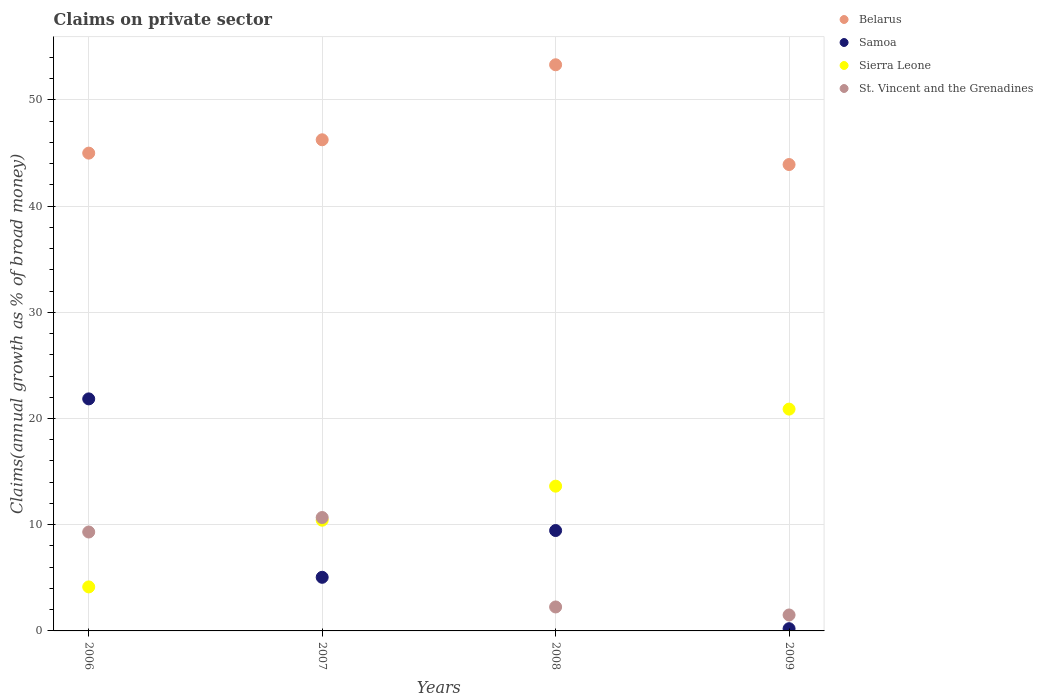How many different coloured dotlines are there?
Offer a very short reply. 4. Is the number of dotlines equal to the number of legend labels?
Keep it short and to the point. Yes. What is the percentage of broad money claimed on private sector in Samoa in 2006?
Your answer should be very brief. 21.85. Across all years, what is the maximum percentage of broad money claimed on private sector in Sierra Leone?
Provide a succinct answer. 20.88. Across all years, what is the minimum percentage of broad money claimed on private sector in Samoa?
Give a very brief answer. 0.21. In which year was the percentage of broad money claimed on private sector in Sierra Leone maximum?
Provide a short and direct response. 2009. What is the total percentage of broad money claimed on private sector in Belarus in the graph?
Offer a very short reply. 188.45. What is the difference between the percentage of broad money claimed on private sector in Belarus in 2006 and that in 2009?
Make the answer very short. 1.07. What is the difference between the percentage of broad money claimed on private sector in Belarus in 2006 and the percentage of broad money claimed on private sector in St. Vincent and the Grenadines in 2007?
Give a very brief answer. 34.31. What is the average percentage of broad money claimed on private sector in St. Vincent and the Grenadines per year?
Make the answer very short. 5.94. In the year 2007, what is the difference between the percentage of broad money claimed on private sector in Samoa and percentage of broad money claimed on private sector in St. Vincent and the Grenadines?
Provide a short and direct response. -5.63. What is the ratio of the percentage of broad money claimed on private sector in Sierra Leone in 2006 to that in 2008?
Offer a very short reply. 0.3. Is the percentage of broad money claimed on private sector in Belarus in 2007 less than that in 2008?
Your response must be concise. Yes. What is the difference between the highest and the second highest percentage of broad money claimed on private sector in St. Vincent and the Grenadines?
Offer a terse response. 1.36. What is the difference between the highest and the lowest percentage of broad money claimed on private sector in St. Vincent and the Grenadines?
Your answer should be compact. 9.18. In how many years, is the percentage of broad money claimed on private sector in Samoa greater than the average percentage of broad money claimed on private sector in Samoa taken over all years?
Provide a short and direct response. 2. Is it the case that in every year, the sum of the percentage of broad money claimed on private sector in Belarus and percentage of broad money claimed on private sector in St. Vincent and the Grenadines  is greater than the sum of percentage of broad money claimed on private sector in Sierra Leone and percentage of broad money claimed on private sector in Samoa?
Your answer should be compact. Yes. Is it the case that in every year, the sum of the percentage of broad money claimed on private sector in St. Vincent and the Grenadines and percentage of broad money claimed on private sector in Sierra Leone  is greater than the percentage of broad money claimed on private sector in Samoa?
Your answer should be very brief. No. Is the percentage of broad money claimed on private sector in St. Vincent and the Grenadines strictly greater than the percentage of broad money claimed on private sector in Sierra Leone over the years?
Give a very brief answer. No. Is the percentage of broad money claimed on private sector in Belarus strictly less than the percentage of broad money claimed on private sector in Sierra Leone over the years?
Your answer should be very brief. No. How many years are there in the graph?
Your response must be concise. 4. What is the difference between two consecutive major ticks on the Y-axis?
Keep it short and to the point. 10. Are the values on the major ticks of Y-axis written in scientific E-notation?
Your answer should be very brief. No. Where does the legend appear in the graph?
Make the answer very short. Top right. How many legend labels are there?
Provide a short and direct response. 4. What is the title of the graph?
Offer a very short reply. Claims on private sector. Does "Sub-Saharan Africa (developing only)" appear as one of the legend labels in the graph?
Keep it short and to the point. No. What is the label or title of the Y-axis?
Make the answer very short. Claims(annual growth as % of broad money). What is the Claims(annual growth as % of broad money) in Belarus in 2006?
Give a very brief answer. 44.99. What is the Claims(annual growth as % of broad money) of Samoa in 2006?
Give a very brief answer. 21.85. What is the Claims(annual growth as % of broad money) of Sierra Leone in 2006?
Your answer should be very brief. 4.14. What is the Claims(annual growth as % of broad money) in St. Vincent and the Grenadines in 2006?
Make the answer very short. 9.31. What is the Claims(annual growth as % of broad money) of Belarus in 2007?
Make the answer very short. 46.24. What is the Claims(annual growth as % of broad money) of Samoa in 2007?
Your response must be concise. 5.05. What is the Claims(annual growth as % of broad money) in Sierra Leone in 2007?
Keep it short and to the point. 10.42. What is the Claims(annual growth as % of broad money) in St. Vincent and the Grenadines in 2007?
Offer a very short reply. 10.68. What is the Claims(annual growth as % of broad money) in Belarus in 2008?
Keep it short and to the point. 53.31. What is the Claims(annual growth as % of broad money) of Samoa in 2008?
Make the answer very short. 9.45. What is the Claims(annual growth as % of broad money) of Sierra Leone in 2008?
Ensure brevity in your answer.  13.63. What is the Claims(annual growth as % of broad money) of St. Vincent and the Grenadines in 2008?
Keep it short and to the point. 2.26. What is the Claims(annual growth as % of broad money) of Belarus in 2009?
Make the answer very short. 43.91. What is the Claims(annual growth as % of broad money) of Samoa in 2009?
Provide a short and direct response. 0.21. What is the Claims(annual growth as % of broad money) of Sierra Leone in 2009?
Provide a short and direct response. 20.88. What is the Claims(annual growth as % of broad money) of St. Vincent and the Grenadines in 2009?
Give a very brief answer. 1.5. Across all years, what is the maximum Claims(annual growth as % of broad money) in Belarus?
Provide a succinct answer. 53.31. Across all years, what is the maximum Claims(annual growth as % of broad money) in Samoa?
Your answer should be very brief. 21.85. Across all years, what is the maximum Claims(annual growth as % of broad money) in Sierra Leone?
Provide a succinct answer. 20.88. Across all years, what is the maximum Claims(annual growth as % of broad money) in St. Vincent and the Grenadines?
Ensure brevity in your answer.  10.68. Across all years, what is the minimum Claims(annual growth as % of broad money) of Belarus?
Provide a short and direct response. 43.91. Across all years, what is the minimum Claims(annual growth as % of broad money) in Samoa?
Give a very brief answer. 0.21. Across all years, what is the minimum Claims(annual growth as % of broad money) of Sierra Leone?
Your answer should be very brief. 4.14. Across all years, what is the minimum Claims(annual growth as % of broad money) in St. Vincent and the Grenadines?
Give a very brief answer. 1.5. What is the total Claims(annual growth as % of broad money) in Belarus in the graph?
Offer a very short reply. 188.45. What is the total Claims(annual growth as % of broad money) of Samoa in the graph?
Make the answer very short. 36.56. What is the total Claims(annual growth as % of broad money) of Sierra Leone in the graph?
Your answer should be very brief. 49.08. What is the total Claims(annual growth as % of broad money) in St. Vincent and the Grenadines in the graph?
Your answer should be very brief. 23.75. What is the difference between the Claims(annual growth as % of broad money) of Belarus in 2006 and that in 2007?
Provide a short and direct response. -1.26. What is the difference between the Claims(annual growth as % of broad money) in Samoa in 2006 and that in 2007?
Offer a terse response. 16.8. What is the difference between the Claims(annual growth as % of broad money) in Sierra Leone in 2006 and that in 2007?
Keep it short and to the point. -6.28. What is the difference between the Claims(annual growth as % of broad money) of St. Vincent and the Grenadines in 2006 and that in 2007?
Keep it short and to the point. -1.36. What is the difference between the Claims(annual growth as % of broad money) of Belarus in 2006 and that in 2008?
Ensure brevity in your answer.  -8.32. What is the difference between the Claims(annual growth as % of broad money) in Samoa in 2006 and that in 2008?
Your answer should be very brief. 12.4. What is the difference between the Claims(annual growth as % of broad money) in Sierra Leone in 2006 and that in 2008?
Give a very brief answer. -9.49. What is the difference between the Claims(annual growth as % of broad money) of St. Vincent and the Grenadines in 2006 and that in 2008?
Offer a terse response. 7.06. What is the difference between the Claims(annual growth as % of broad money) of Belarus in 2006 and that in 2009?
Give a very brief answer. 1.07. What is the difference between the Claims(annual growth as % of broad money) of Samoa in 2006 and that in 2009?
Provide a short and direct response. 21.64. What is the difference between the Claims(annual growth as % of broad money) of Sierra Leone in 2006 and that in 2009?
Keep it short and to the point. -16.74. What is the difference between the Claims(annual growth as % of broad money) in St. Vincent and the Grenadines in 2006 and that in 2009?
Your answer should be very brief. 7.81. What is the difference between the Claims(annual growth as % of broad money) of Belarus in 2007 and that in 2008?
Offer a very short reply. -7.06. What is the difference between the Claims(annual growth as % of broad money) in Samoa in 2007 and that in 2008?
Give a very brief answer. -4.4. What is the difference between the Claims(annual growth as % of broad money) of Sierra Leone in 2007 and that in 2008?
Provide a succinct answer. -3.21. What is the difference between the Claims(annual growth as % of broad money) in St. Vincent and the Grenadines in 2007 and that in 2008?
Provide a short and direct response. 8.42. What is the difference between the Claims(annual growth as % of broad money) of Belarus in 2007 and that in 2009?
Offer a terse response. 2.33. What is the difference between the Claims(annual growth as % of broad money) of Samoa in 2007 and that in 2009?
Provide a succinct answer. 4.84. What is the difference between the Claims(annual growth as % of broad money) of Sierra Leone in 2007 and that in 2009?
Your answer should be compact. -10.46. What is the difference between the Claims(annual growth as % of broad money) of St. Vincent and the Grenadines in 2007 and that in 2009?
Offer a terse response. 9.18. What is the difference between the Claims(annual growth as % of broad money) in Belarus in 2008 and that in 2009?
Your response must be concise. 9.39. What is the difference between the Claims(annual growth as % of broad money) of Samoa in 2008 and that in 2009?
Provide a short and direct response. 9.24. What is the difference between the Claims(annual growth as % of broad money) in Sierra Leone in 2008 and that in 2009?
Ensure brevity in your answer.  -7.25. What is the difference between the Claims(annual growth as % of broad money) of St. Vincent and the Grenadines in 2008 and that in 2009?
Keep it short and to the point. 0.75. What is the difference between the Claims(annual growth as % of broad money) of Belarus in 2006 and the Claims(annual growth as % of broad money) of Samoa in 2007?
Make the answer very short. 39.94. What is the difference between the Claims(annual growth as % of broad money) of Belarus in 2006 and the Claims(annual growth as % of broad money) of Sierra Leone in 2007?
Your answer should be compact. 34.56. What is the difference between the Claims(annual growth as % of broad money) in Belarus in 2006 and the Claims(annual growth as % of broad money) in St. Vincent and the Grenadines in 2007?
Ensure brevity in your answer.  34.31. What is the difference between the Claims(annual growth as % of broad money) of Samoa in 2006 and the Claims(annual growth as % of broad money) of Sierra Leone in 2007?
Offer a very short reply. 11.42. What is the difference between the Claims(annual growth as % of broad money) of Samoa in 2006 and the Claims(annual growth as % of broad money) of St. Vincent and the Grenadines in 2007?
Provide a succinct answer. 11.17. What is the difference between the Claims(annual growth as % of broad money) of Sierra Leone in 2006 and the Claims(annual growth as % of broad money) of St. Vincent and the Grenadines in 2007?
Provide a succinct answer. -6.53. What is the difference between the Claims(annual growth as % of broad money) in Belarus in 2006 and the Claims(annual growth as % of broad money) in Samoa in 2008?
Ensure brevity in your answer.  35.54. What is the difference between the Claims(annual growth as % of broad money) of Belarus in 2006 and the Claims(annual growth as % of broad money) of Sierra Leone in 2008?
Your response must be concise. 31.36. What is the difference between the Claims(annual growth as % of broad money) of Belarus in 2006 and the Claims(annual growth as % of broad money) of St. Vincent and the Grenadines in 2008?
Ensure brevity in your answer.  42.73. What is the difference between the Claims(annual growth as % of broad money) of Samoa in 2006 and the Claims(annual growth as % of broad money) of Sierra Leone in 2008?
Your response must be concise. 8.22. What is the difference between the Claims(annual growth as % of broad money) of Samoa in 2006 and the Claims(annual growth as % of broad money) of St. Vincent and the Grenadines in 2008?
Ensure brevity in your answer.  19.59. What is the difference between the Claims(annual growth as % of broad money) in Sierra Leone in 2006 and the Claims(annual growth as % of broad money) in St. Vincent and the Grenadines in 2008?
Give a very brief answer. 1.89. What is the difference between the Claims(annual growth as % of broad money) of Belarus in 2006 and the Claims(annual growth as % of broad money) of Samoa in 2009?
Your answer should be compact. 44.78. What is the difference between the Claims(annual growth as % of broad money) in Belarus in 2006 and the Claims(annual growth as % of broad money) in Sierra Leone in 2009?
Your answer should be compact. 24.1. What is the difference between the Claims(annual growth as % of broad money) in Belarus in 2006 and the Claims(annual growth as % of broad money) in St. Vincent and the Grenadines in 2009?
Provide a short and direct response. 43.49. What is the difference between the Claims(annual growth as % of broad money) of Samoa in 2006 and the Claims(annual growth as % of broad money) of Sierra Leone in 2009?
Give a very brief answer. 0.96. What is the difference between the Claims(annual growth as % of broad money) in Samoa in 2006 and the Claims(annual growth as % of broad money) in St. Vincent and the Grenadines in 2009?
Give a very brief answer. 20.35. What is the difference between the Claims(annual growth as % of broad money) in Sierra Leone in 2006 and the Claims(annual growth as % of broad money) in St. Vincent and the Grenadines in 2009?
Offer a terse response. 2.64. What is the difference between the Claims(annual growth as % of broad money) in Belarus in 2007 and the Claims(annual growth as % of broad money) in Samoa in 2008?
Ensure brevity in your answer.  36.79. What is the difference between the Claims(annual growth as % of broad money) in Belarus in 2007 and the Claims(annual growth as % of broad money) in Sierra Leone in 2008?
Provide a short and direct response. 32.61. What is the difference between the Claims(annual growth as % of broad money) of Belarus in 2007 and the Claims(annual growth as % of broad money) of St. Vincent and the Grenadines in 2008?
Offer a very short reply. 43.99. What is the difference between the Claims(annual growth as % of broad money) in Samoa in 2007 and the Claims(annual growth as % of broad money) in Sierra Leone in 2008?
Offer a terse response. -8.58. What is the difference between the Claims(annual growth as % of broad money) in Samoa in 2007 and the Claims(annual growth as % of broad money) in St. Vincent and the Grenadines in 2008?
Provide a short and direct response. 2.79. What is the difference between the Claims(annual growth as % of broad money) of Sierra Leone in 2007 and the Claims(annual growth as % of broad money) of St. Vincent and the Grenadines in 2008?
Offer a terse response. 8.17. What is the difference between the Claims(annual growth as % of broad money) in Belarus in 2007 and the Claims(annual growth as % of broad money) in Samoa in 2009?
Your answer should be very brief. 46.03. What is the difference between the Claims(annual growth as % of broad money) in Belarus in 2007 and the Claims(annual growth as % of broad money) in Sierra Leone in 2009?
Provide a short and direct response. 25.36. What is the difference between the Claims(annual growth as % of broad money) in Belarus in 2007 and the Claims(annual growth as % of broad money) in St. Vincent and the Grenadines in 2009?
Give a very brief answer. 44.74. What is the difference between the Claims(annual growth as % of broad money) in Samoa in 2007 and the Claims(annual growth as % of broad money) in Sierra Leone in 2009?
Your answer should be compact. -15.84. What is the difference between the Claims(annual growth as % of broad money) in Samoa in 2007 and the Claims(annual growth as % of broad money) in St. Vincent and the Grenadines in 2009?
Give a very brief answer. 3.55. What is the difference between the Claims(annual growth as % of broad money) of Sierra Leone in 2007 and the Claims(annual growth as % of broad money) of St. Vincent and the Grenadines in 2009?
Offer a terse response. 8.92. What is the difference between the Claims(annual growth as % of broad money) in Belarus in 2008 and the Claims(annual growth as % of broad money) in Samoa in 2009?
Your answer should be very brief. 53.1. What is the difference between the Claims(annual growth as % of broad money) of Belarus in 2008 and the Claims(annual growth as % of broad money) of Sierra Leone in 2009?
Offer a terse response. 32.42. What is the difference between the Claims(annual growth as % of broad money) of Belarus in 2008 and the Claims(annual growth as % of broad money) of St. Vincent and the Grenadines in 2009?
Keep it short and to the point. 51.81. What is the difference between the Claims(annual growth as % of broad money) in Samoa in 2008 and the Claims(annual growth as % of broad money) in Sierra Leone in 2009?
Offer a terse response. -11.43. What is the difference between the Claims(annual growth as % of broad money) in Samoa in 2008 and the Claims(annual growth as % of broad money) in St. Vincent and the Grenadines in 2009?
Offer a very short reply. 7.95. What is the difference between the Claims(annual growth as % of broad money) in Sierra Leone in 2008 and the Claims(annual growth as % of broad money) in St. Vincent and the Grenadines in 2009?
Your answer should be very brief. 12.13. What is the average Claims(annual growth as % of broad money) in Belarus per year?
Ensure brevity in your answer.  47.11. What is the average Claims(annual growth as % of broad money) of Samoa per year?
Your response must be concise. 9.14. What is the average Claims(annual growth as % of broad money) in Sierra Leone per year?
Make the answer very short. 12.27. What is the average Claims(annual growth as % of broad money) of St. Vincent and the Grenadines per year?
Keep it short and to the point. 5.94. In the year 2006, what is the difference between the Claims(annual growth as % of broad money) of Belarus and Claims(annual growth as % of broad money) of Samoa?
Make the answer very short. 23.14. In the year 2006, what is the difference between the Claims(annual growth as % of broad money) in Belarus and Claims(annual growth as % of broad money) in Sierra Leone?
Your response must be concise. 40.84. In the year 2006, what is the difference between the Claims(annual growth as % of broad money) of Belarus and Claims(annual growth as % of broad money) of St. Vincent and the Grenadines?
Provide a short and direct response. 35.67. In the year 2006, what is the difference between the Claims(annual growth as % of broad money) in Samoa and Claims(annual growth as % of broad money) in Sierra Leone?
Offer a terse response. 17.7. In the year 2006, what is the difference between the Claims(annual growth as % of broad money) in Samoa and Claims(annual growth as % of broad money) in St. Vincent and the Grenadines?
Offer a terse response. 12.53. In the year 2006, what is the difference between the Claims(annual growth as % of broad money) of Sierra Leone and Claims(annual growth as % of broad money) of St. Vincent and the Grenadines?
Ensure brevity in your answer.  -5.17. In the year 2007, what is the difference between the Claims(annual growth as % of broad money) of Belarus and Claims(annual growth as % of broad money) of Samoa?
Make the answer very short. 41.2. In the year 2007, what is the difference between the Claims(annual growth as % of broad money) of Belarus and Claims(annual growth as % of broad money) of Sierra Leone?
Keep it short and to the point. 35.82. In the year 2007, what is the difference between the Claims(annual growth as % of broad money) of Belarus and Claims(annual growth as % of broad money) of St. Vincent and the Grenadines?
Make the answer very short. 35.57. In the year 2007, what is the difference between the Claims(annual growth as % of broad money) of Samoa and Claims(annual growth as % of broad money) of Sierra Leone?
Provide a succinct answer. -5.38. In the year 2007, what is the difference between the Claims(annual growth as % of broad money) of Samoa and Claims(annual growth as % of broad money) of St. Vincent and the Grenadines?
Your answer should be compact. -5.63. In the year 2007, what is the difference between the Claims(annual growth as % of broad money) in Sierra Leone and Claims(annual growth as % of broad money) in St. Vincent and the Grenadines?
Ensure brevity in your answer.  -0.25. In the year 2008, what is the difference between the Claims(annual growth as % of broad money) of Belarus and Claims(annual growth as % of broad money) of Samoa?
Provide a succinct answer. 43.85. In the year 2008, what is the difference between the Claims(annual growth as % of broad money) in Belarus and Claims(annual growth as % of broad money) in Sierra Leone?
Your answer should be compact. 39.68. In the year 2008, what is the difference between the Claims(annual growth as % of broad money) in Belarus and Claims(annual growth as % of broad money) in St. Vincent and the Grenadines?
Make the answer very short. 51.05. In the year 2008, what is the difference between the Claims(annual growth as % of broad money) of Samoa and Claims(annual growth as % of broad money) of Sierra Leone?
Your response must be concise. -4.18. In the year 2008, what is the difference between the Claims(annual growth as % of broad money) in Samoa and Claims(annual growth as % of broad money) in St. Vincent and the Grenadines?
Your response must be concise. 7.2. In the year 2008, what is the difference between the Claims(annual growth as % of broad money) of Sierra Leone and Claims(annual growth as % of broad money) of St. Vincent and the Grenadines?
Provide a succinct answer. 11.37. In the year 2009, what is the difference between the Claims(annual growth as % of broad money) in Belarus and Claims(annual growth as % of broad money) in Samoa?
Ensure brevity in your answer.  43.7. In the year 2009, what is the difference between the Claims(annual growth as % of broad money) of Belarus and Claims(annual growth as % of broad money) of Sierra Leone?
Your response must be concise. 23.03. In the year 2009, what is the difference between the Claims(annual growth as % of broad money) of Belarus and Claims(annual growth as % of broad money) of St. Vincent and the Grenadines?
Ensure brevity in your answer.  42.41. In the year 2009, what is the difference between the Claims(annual growth as % of broad money) of Samoa and Claims(annual growth as % of broad money) of Sierra Leone?
Offer a terse response. -20.67. In the year 2009, what is the difference between the Claims(annual growth as % of broad money) of Samoa and Claims(annual growth as % of broad money) of St. Vincent and the Grenadines?
Your response must be concise. -1.29. In the year 2009, what is the difference between the Claims(annual growth as % of broad money) in Sierra Leone and Claims(annual growth as % of broad money) in St. Vincent and the Grenadines?
Offer a very short reply. 19.38. What is the ratio of the Claims(annual growth as % of broad money) of Belarus in 2006 to that in 2007?
Provide a succinct answer. 0.97. What is the ratio of the Claims(annual growth as % of broad money) in Samoa in 2006 to that in 2007?
Provide a short and direct response. 4.33. What is the ratio of the Claims(annual growth as % of broad money) of Sierra Leone in 2006 to that in 2007?
Provide a short and direct response. 0.4. What is the ratio of the Claims(annual growth as % of broad money) in St. Vincent and the Grenadines in 2006 to that in 2007?
Offer a very short reply. 0.87. What is the ratio of the Claims(annual growth as % of broad money) in Belarus in 2006 to that in 2008?
Provide a short and direct response. 0.84. What is the ratio of the Claims(annual growth as % of broad money) of Samoa in 2006 to that in 2008?
Keep it short and to the point. 2.31. What is the ratio of the Claims(annual growth as % of broad money) in Sierra Leone in 2006 to that in 2008?
Your answer should be compact. 0.3. What is the ratio of the Claims(annual growth as % of broad money) of St. Vincent and the Grenadines in 2006 to that in 2008?
Offer a terse response. 4.13. What is the ratio of the Claims(annual growth as % of broad money) of Belarus in 2006 to that in 2009?
Provide a short and direct response. 1.02. What is the ratio of the Claims(annual growth as % of broad money) of Samoa in 2006 to that in 2009?
Your response must be concise. 104.04. What is the ratio of the Claims(annual growth as % of broad money) in Sierra Leone in 2006 to that in 2009?
Make the answer very short. 0.2. What is the ratio of the Claims(annual growth as % of broad money) of St. Vincent and the Grenadines in 2006 to that in 2009?
Provide a short and direct response. 6.2. What is the ratio of the Claims(annual growth as % of broad money) of Belarus in 2007 to that in 2008?
Your answer should be very brief. 0.87. What is the ratio of the Claims(annual growth as % of broad money) in Samoa in 2007 to that in 2008?
Ensure brevity in your answer.  0.53. What is the ratio of the Claims(annual growth as % of broad money) in Sierra Leone in 2007 to that in 2008?
Provide a short and direct response. 0.76. What is the ratio of the Claims(annual growth as % of broad money) of St. Vincent and the Grenadines in 2007 to that in 2008?
Offer a terse response. 4.73. What is the ratio of the Claims(annual growth as % of broad money) of Belarus in 2007 to that in 2009?
Your answer should be very brief. 1.05. What is the ratio of the Claims(annual growth as % of broad money) of Samoa in 2007 to that in 2009?
Provide a succinct answer. 24.04. What is the ratio of the Claims(annual growth as % of broad money) of Sierra Leone in 2007 to that in 2009?
Ensure brevity in your answer.  0.5. What is the ratio of the Claims(annual growth as % of broad money) of St. Vincent and the Grenadines in 2007 to that in 2009?
Your answer should be very brief. 7.11. What is the ratio of the Claims(annual growth as % of broad money) of Belarus in 2008 to that in 2009?
Your response must be concise. 1.21. What is the ratio of the Claims(annual growth as % of broad money) of Samoa in 2008 to that in 2009?
Offer a terse response. 45.01. What is the ratio of the Claims(annual growth as % of broad money) in Sierra Leone in 2008 to that in 2009?
Give a very brief answer. 0.65. What is the ratio of the Claims(annual growth as % of broad money) of St. Vincent and the Grenadines in 2008 to that in 2009?
Keep it short and to the point. 1.5. What is the difference between the highest and the second highest Claims(annual growth as % of broad money) of Belarus?
Your answer should be compact. 7.06. What is the difference between the highest and the second highest Claims(annual growth as % of broad money) of Samoa?
Offer a terse response. 12.4. What is the difference between the highest and the second highest Claims(annual growth as % of broad money) in Sierra Leone?
Ensure brevity in your answer.  7.25. What is the difference between the highest and the second highest Claims(annual growth as % of broad money) of St. Vincent and the Grenadines?
Offer a terse response. 1.36. What is the difference between the highest and the lowest Claims(annual growth as % of broad money) in Belarus?
Your response must be concise. 9.39. What is the difference between the highest and the lowest Claims(annual growth as % of broad money) of Samoa?
Make the answer very short. 21.64. What is the difference between the highest and the lowest Claims(annual growth as % of broad money) of Sierra Leone?
Provide a short and direct response. 16.74. What is the difference between the highest and the lowest Claims(annual growth as % of broad money) in St. Vincent and the Grenadines?
Offer a very short reply. 9.18. 